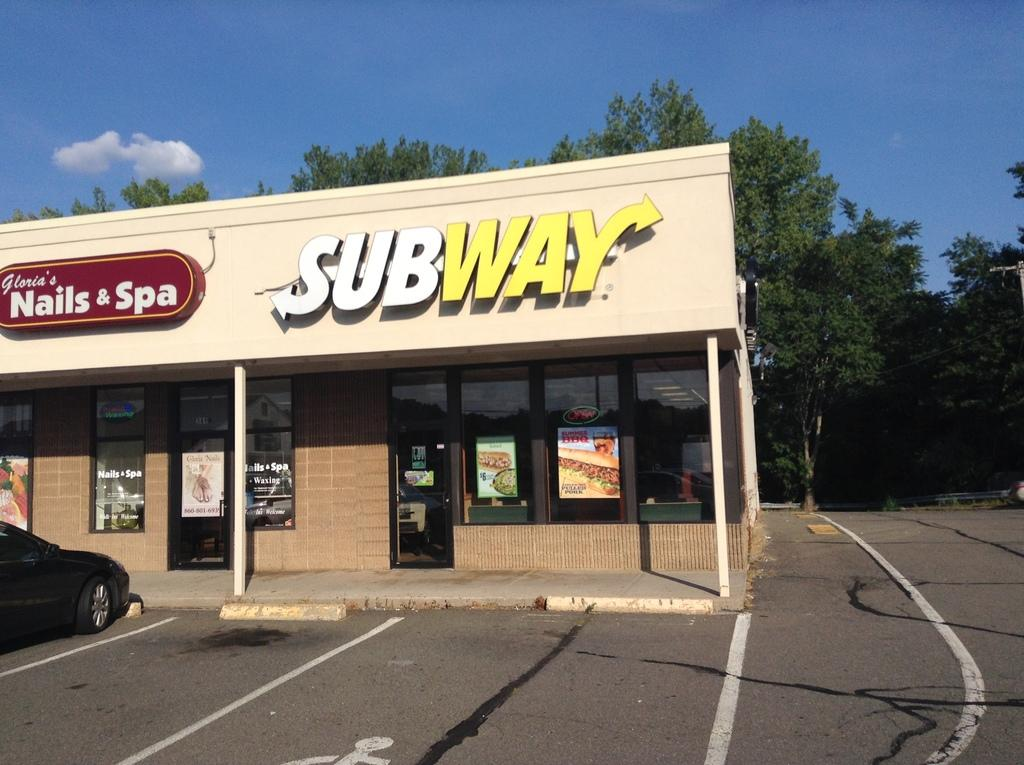What type of establishment is shown in the image? There is a subway shop in the image. What can be seen in the foreground of the image? There is a road in the front bottom side of the image. What is visible in the background of the image? There are trees visible in the background of the image. How many girls are playing with polish in the image? There are no girls or any mention of polish in the image. 